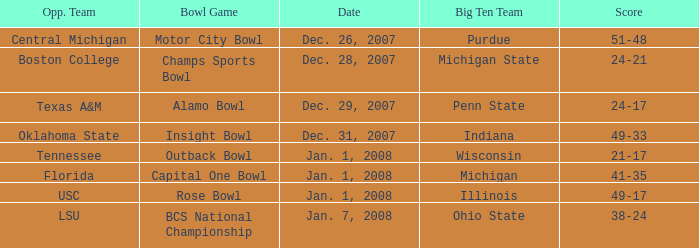What was the score of the Insight Bowl? 49-33. 